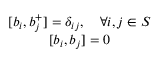<formula> <loc_0><loc_0><loc_500><loc_500>\begin{array} { c } { { [ b _ { i } , b _ { j } ^ { + } ] = \delta _ { i j } , \quad \forall i , j \in S } } \\ { { [ b _ { i } , b _ { j } ] = 0 } } \end{array}</formula> 